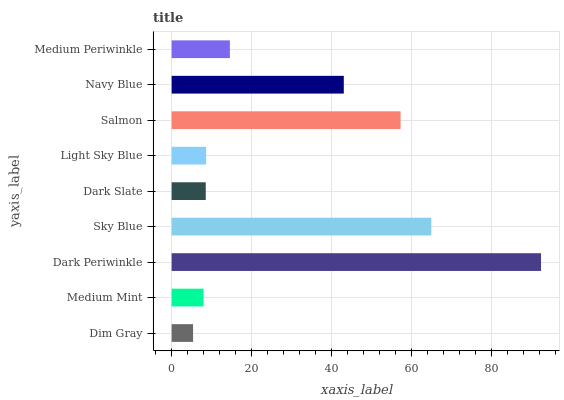Is Dim Gray the minimum?
Answer yes or no. Yes. Is Dark Periwinkle the maximum?
Answer yes or no. Yes. Is Medium Mint the minimum?
Answer yes or no. No. Is Medium Mint the maximum?
Answer yes or no. No. Is Medium Mint greater than Dim Gray?
Answer yes or no. Yes. Is Dim Gray less than Medium Mint?
Answer yes or no. Yes. Is Dim Gray greater than Medium Mint?
Answer yes or no. No. Is Medium Mint less than Dim Gray?
Answer yes or no. No. Is Medium Periwinkle the high median?
Answer yes or no. Yes. Is Medium Periwinkle the low median?
Answer yes or no. Yes. Is Light Sky Blue the high median?
Answer yes or no. No. Is Dark Slate the low median?
Answer yes or no. No. 